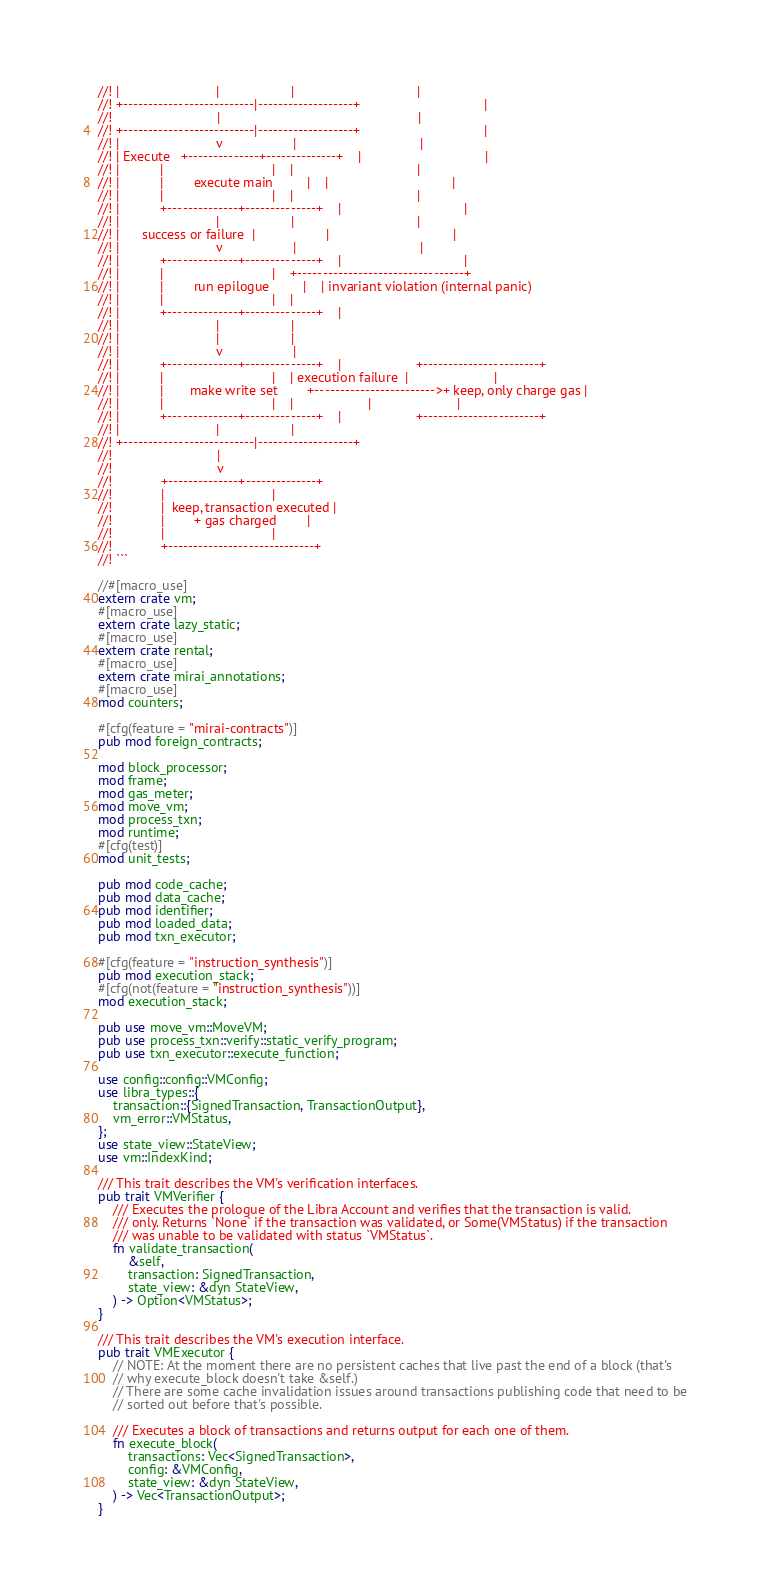<code> <loc_0><loc_0><loc_500><loc_500><_Rust_>//! |                          |                   |                                 |
//! +--------------------------|-------------------+                                 |
//!                            |                                                     |
//! +--------------------------|-------------------+                                 |
//! |                          v                   |                                 |
//! | Execute   +--------------+--------------+    |                                 |
//! |           |                             |    |                                 |
//! |           |        execute main         |    |                                 |
//! |           |                             |    |                                 |
//! |           +--------------+--------------+    |                                 |
//! |                          |                   |                                 |
//! |      success or failure  |                   |                                 |
//! |                          v                   |                                 |
//! |           +--------------+--------------+    |                                 |
//! |           |                             |    +---------------------------------+
//! |           |        run epilogue         |    | invariant violation (internal panic)
//! |           |                             |    |
//! |           +--------------+--------------+    |
//! |                          |                   |
//! |                          |                   |
//! |                          v                   |
//! |           +--------------+--------------+    |                    +-----------------------+
//! |           |                             |    | execution failure  |                       |
//! |           |       make write set        +------------------------>+ keep, only charge gas |
//! |           |                             |    |                    |                       |
//! |           +--------------+--------------+    |                    +-----------------------+
//! |                          |                   |
//! +--------------------------|-------------------+
//!                            |
//!                            v
//!             +--------------+--------------+
//!             |                             |
//!             |  keep, transaction executed |
//!             |        + gas charged        |
//!             |                             |
//!             +-----------------------------+
//! ```

//#[macro_use]
extern crate vm;
#[macro_use]
extern crate lazy_static;
#[macro_use]
extern crate rental;
#[macro_use]
extern crate mirai_annotations;
#[macro_use]
mod counters;

#[cfg(feature = "mirai-contracts")]
pub mod foreign_contracts;

mod block_processor;
mod frame;
mod gas_meter;
mod move_vm;
mod process_txn;
mod runtime;
#[cfg(test)]
mod unit_tests;

pub mod code_cache;
pub mod data_cache;
pub mod identifier;
pub mod loaded_data;
pub mod txn_executor;

#[cfg(feature = "instruction_synthesis")]
pub mod execution_stack;
#[cfg(not(feature = "instruction_synthesis"))]
mod execution_stack;

pub use move_vm::MoveVM;
pub use process_txn::verify::static_verify_program;
pub use txn_executor::execute_function;

use config::config::VMConfig;
use libra_types::{
    transaction::{SignedTransaction, TransactionOutput},
    vm_error::VMStatus,
};
use state_view::StateView;
use vm::IndexKind;

/// This trait describes the VM's verification interfaces.
pub trait VMVerifier {
    /// Executes the prologue of the Libra Account and verifies that the transaction is valid.
    /// only. Returns `None` if the transaction was validated, or Some(VMStatus) if the transaction
    /// was unable to be validated with status `VMStatus`.
    fn validate_transaction(
        &self,
        transaction: SignedTransaction,
        state_view: &dyn StateView,
    ) -> Option<VMStatus>;
}

/// This trait describes the VM's execution interface.
pub trait VMExecutor {
    // NOTE: At the moment there are no persistent caches that live past the end of a block (that's
    // why execute_block doesn't take &self.)
    // There are some cache invalidation issues around transactions publishing code that need to be
    // sorted out before that's possible.

    /// Executes a block of transactions and returns output for each one of them.
    fn execute_block(
        transactions: Vec<SignedTransaction>,
        config: &VMConfig,
        state_view: &dyn StateView,
    ) -> Vec<TransactionOutput>;
}
</code> 